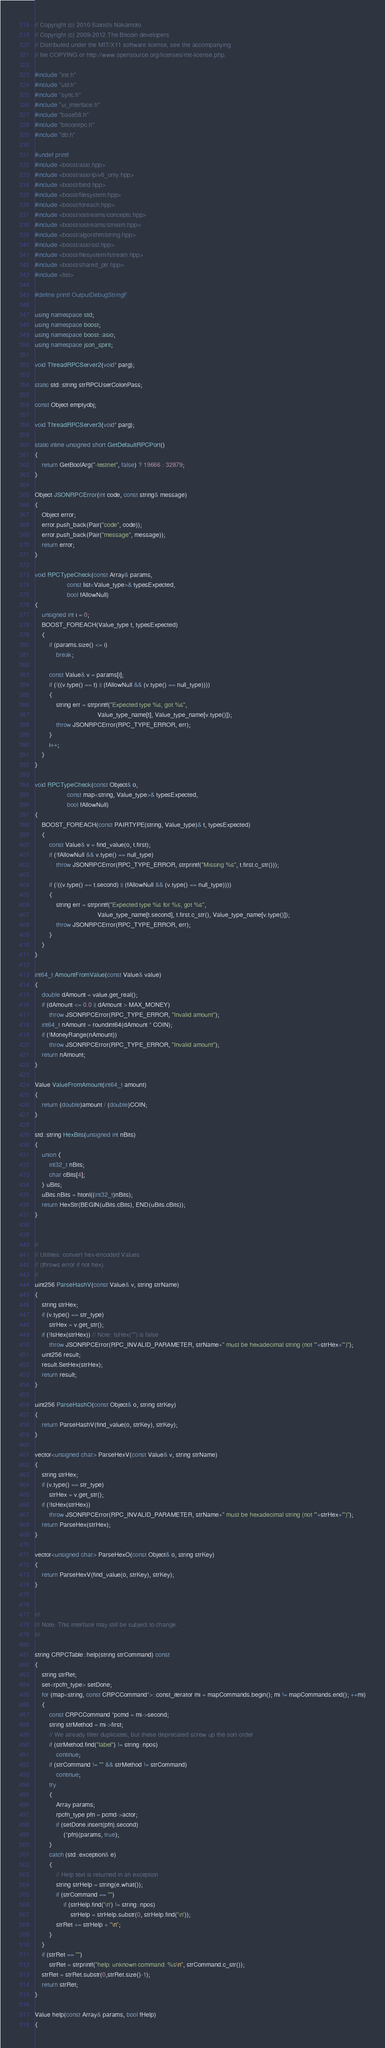<code> <loc_0><loc_0><loc_500><loc_500><_C++_>// Copyright (c) 2010 Satoshi Nakamoto
// Copyright (c) 2009-2012 The Bitcoin developers
// Distributed under the MIT/X11 software license, see the accompanying
// file COPYING or http://www.opensource.org/licenses/mit-license.php.

#include "init.h"
#include "util.h"
#include "sync.h"
#include "ui_interface.h"
#include "base58.h"
#include "bitcoinrpc.h"
#include "db.h"

#undef printf
#include <boost/asio.hpp>
#include <boost/asio/ip/v6_only.hpp>
#include <boost/bind.hpp>
#include <boost/filesystem.hpp>
#include <boost/foreach.hpp>
#include <boost/iostreams/concepts.hpp>
#include <boost/iostreams/stream.hpp>
#include <boost/algorithm/string.hpp>
#include <boost/asio/ssl.hpp>
#include <boost/filesystem/fstream.hpp>
#include <boost/shared_ptr.hpp>
#include <list>

#define printf OutputDebugStringF

using namespace std;
using namespace boost;
using namespace boost::asio;
using namespace json_spirit;

void ThreadRPCServer2(void* parg);

static std::string strRPCUserColonPass;

const Object emptyobj;

void ThreadRPCServer3(void* parg);

static inline unsigned short GetDefaultRPCPort()
{
    return GetBoolArg("-testnet", false) ? 19666 : 32879;
}

Object JSONRPCError(int code, const string& message)
{
    Object error;
    error.push_back(Pair("code", code));
    error.push_back(Pair("message", message));
    return error;
}

void RPCTypeCheck(const Array& params,
                  const list<Value_type>& typesExpected,
                  bool fAllowNull)
{
    unsigned int i = 0;
    BOOST_FOREACH(Value_type t, typesExpected)
    {
        if (params.size() <= i)
            break;

        const Value& v = params[i];
        if (!((v.type() == t) || (fAllowNull && (v.type() == null_type))))
        {
            string err = strprintf("Expected type %s, got %s",
                                   Value_type_name[t], Value_type_name[v.type()]);
            throw JSONRPCError(RPC_TYPE_ERROR, err);
        }
        i++;
    }
}

void RPCTypeCheck(const Object& o,
                  const map<string, Value_type>& typesExpected,
                  bool fAllowNull)
{
    BOOST_FOREACH(const PAIRTYPE(string, Value_type)& t, typesExpected)
    {
        const Value& v = find_value(o, t.first);
        if (!fAllowNull && v.type() == null_type)
            throw JSONRPCError(RPC_TYPE_ERROR, strprintf("Missing %s", t.first.c_str()));

        if (!((v.type() == t.second) || (fAllowNull && (v.type() == null_type))))
        {
            string err = strprintf("Expected type %s for %s, got %s",
                                   Value_type_name[t.second], t.first.c_str(), Value_type_name[v.type()]);
            throw JSONRPCError(RPC_TYPE_ERROR, err);
        }
    }
}

int64_t AmountFromValue(const Value& value)
{
    double dAmount = value.get_real();
    if (dAmount <= 0.0 || dAmount > MAX_MONEY)
        throw JSONRPCError(RPC_TYPE_ERROR, "Invalid amount");
    int64_t nAmount = roundint64(dAmount * COIN);
    if (!MoneyRange(nAmount))
        throw JSONRPCError(RPC_TYPE_ERROR, "Invalid amount");
    return nAmount;
}

Value ValueFromAmount(int64_t amount)
{
    return (double)amount / (double)COIN;
}

std::string HexBits(unsigned int nBits)
{
    union {
        int32_t nBits;
        char cBits[4];
    } uBits;
    uBits.nBits = htonl((int32_t)nBits);
    return HexStr(BEGIN(uBits.cBits), END(uBits.cBits));
}


//
// Utilities: convert hex-encoded Values
// (throws error if not hex).
//
uint256 ParseHashV(const Value& v, string strName)
{
    string strHex;
    if (v.type() == str_type)
        strHex = v.get_str();
    if (!IsHex(strHex)) // Note: IsHex("") is false
        throw JSONRPCError(RPC_INVALID_PARAMETER, strName+" must be hexadecimal string (not '"+strHex+"')");
    uint256 result;
    result.SetHex(strHex);
    return result;
}

uint256 ParseHashO(const Object& o, string strKey)
{
    return ParseHashV(find_value(o, strKey), strKey);
}

vector<unsigned char> ParseHexV(const Value& v, string strName)
{
    string strHex;
    if (v.type() == str_type)
        strHex = v.get_str();
    if (!IsHex(strHex))
        throw JSONRPCError(RPC_INVALID_PARAMETER, strName+" must be hexadecimal string (not '"+strHex+"')");
    return ParseHex(strHex);
}

vector<unsigned char> ParseHexO(const Object& o, string strKey)
{
    return ParseHexV(find_value(o, strKey), strKey);
}


///
/// Note: This interface may still be subject to change.
///

string CRPCTable::help(string strCommand) const
{
    string strRet;
    set<rpcfn_type> setDone;
    for (map<string, const CRPCCommand*>::const_iterator mi = mapCommands.begin(); mi != mapCommands.end(); ++mi)
    {
        const CRPCCommand *pcmd = mi->second;
        string strMethod = mi->first;
        // We already filter duplicates, but these deprecated screw up the sort order
        if (strMethod.find("label") != string::npos)
            continue;
        if (strCommand != "" && strMethod != strCommand)
            continue;
        try
        {
            Array params;
            rpcfn_type pfn = pcmd->actor;
            if (setDone.insert(pfn).second)
                (*pfn)(params, true);
        }
        catch (std::exception& e)
        {
            // Help text is returned in an exception
            string strHelp = string(e.what());
            if (strCommand == "")
                if (strHelp.find('\n') != string::npos)
                    strHelp = strHelp.substr(0, strHelp.find('\n'));
            strRet += strHelp + "\n";
        }
    }
    if (strRet == "")
        strRet = strprintf("help: unknown command: %s\n", strCommand.c_str());
    strRet = strRet.substr(0,strRet.size()-1);
    return strRet;
}

Value help(const Array& params, bool fHelp)
{</code> 